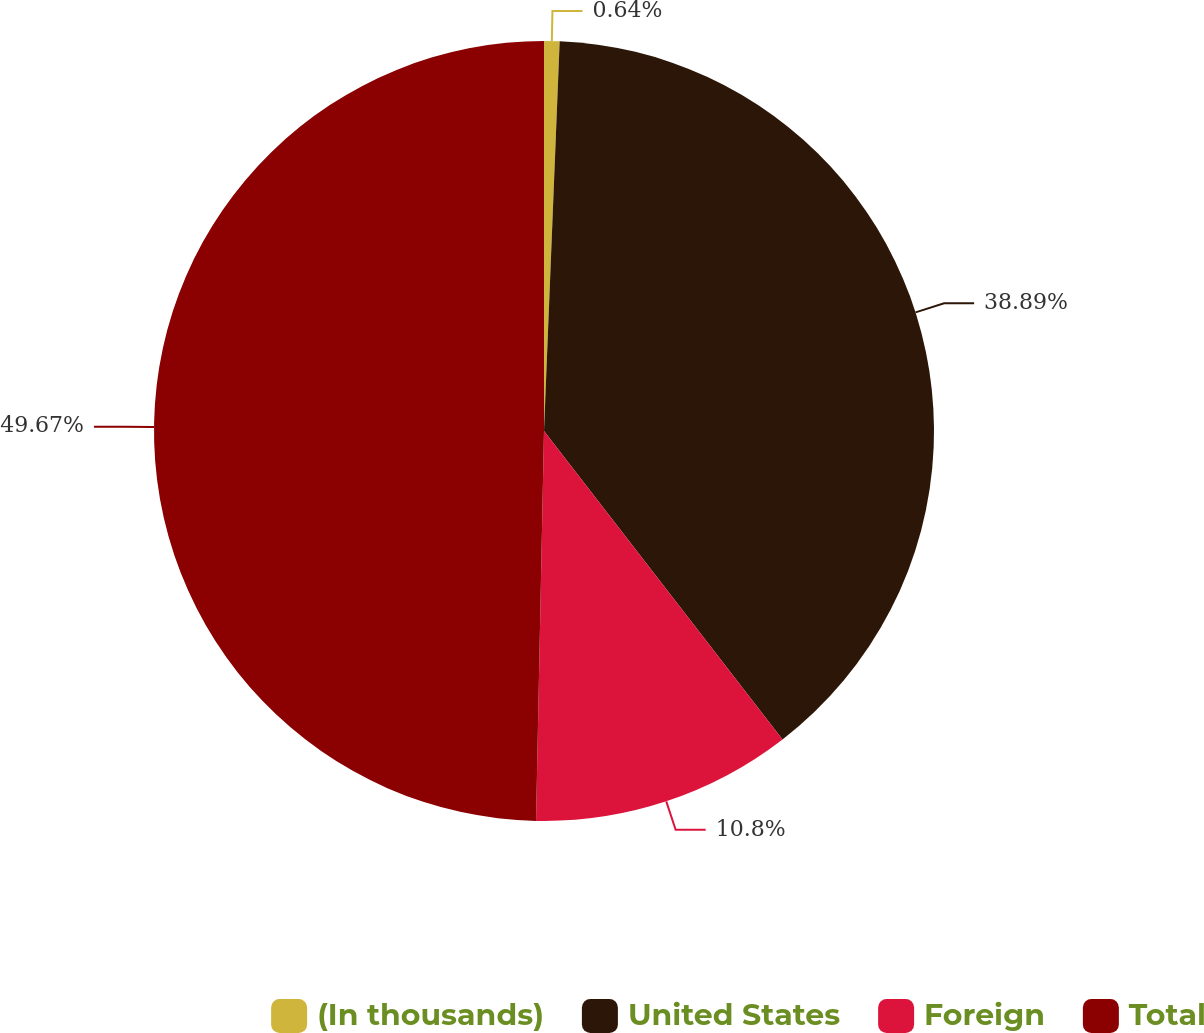Convert chart to OTSL. <chart><loc_0><loc_0><loc_500><loc_500><pie_chart><fcel>(In thousands)<fcel>United States<fcel>Foreign<fcel>Total<nl><fcel>0.64%<fcel>38.89%<fcel>10.8%<fcel>49.68%<nl></chart> 